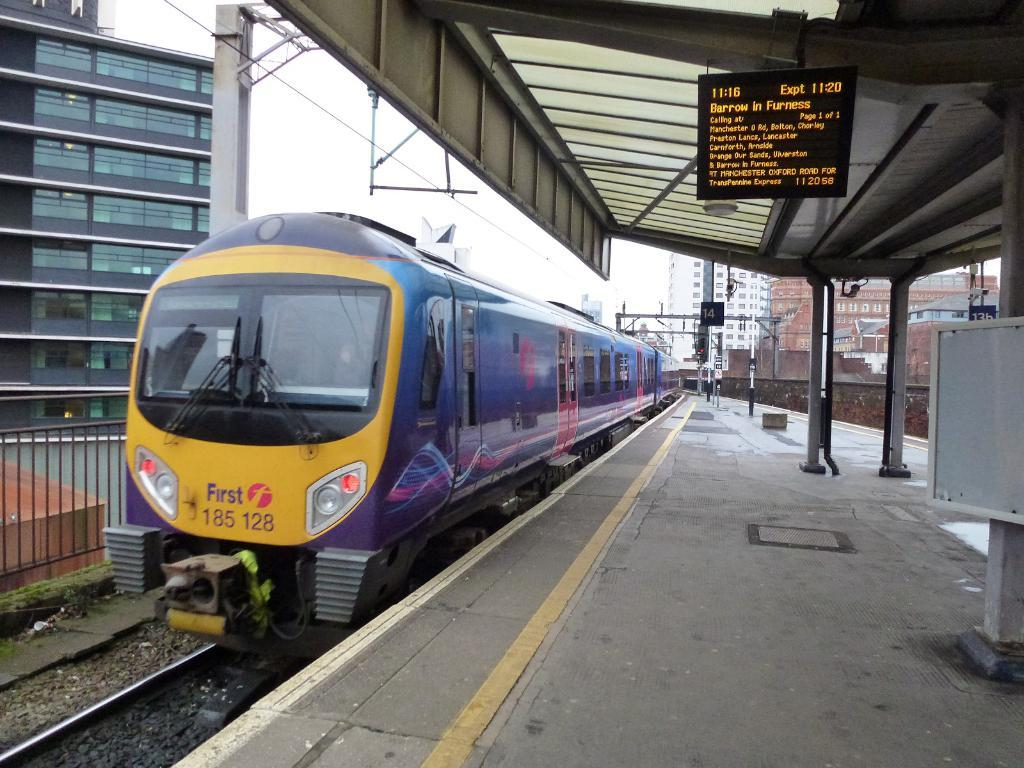<image>
Provide a brief description of the given image. A purple train at the Barrow in Furness stop is on the tracks. 